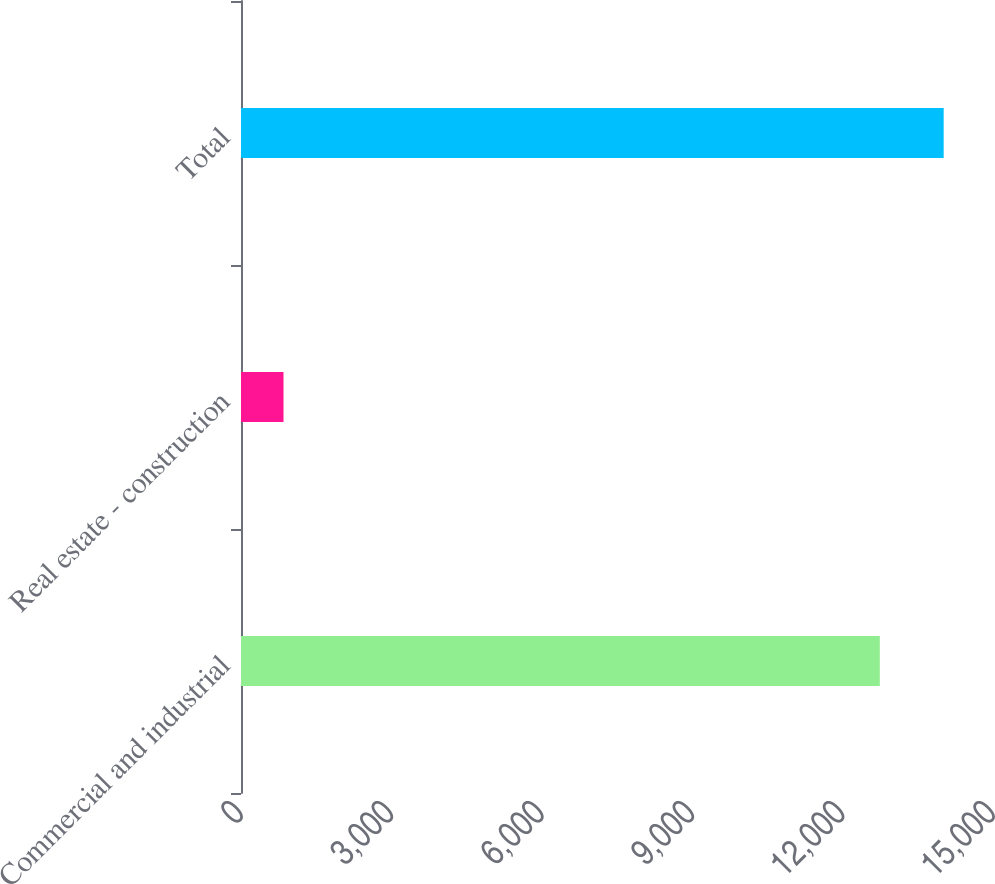Convert chart to OTSL. <chart><loc_0><loc_0><loc_500><loc_500><bar_chart><fcel>Commercial and industrial<fcel>Real estate - construction<fcel>Total<nl><fcel>12742<fcel>848<fcel>14016.2<nl></chart> 